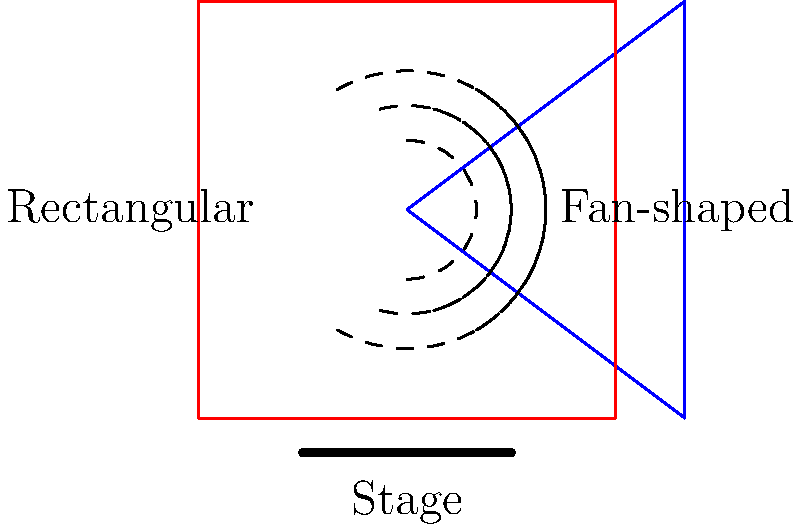As a classical music critic analyzing the interpretation of compositions, which auditorium seating layout would you recommend for optimal sound dispersion and why: fan-shaped or rectangular? To answer this question, we need to consider the acoustical properties of both layouts:

1. Fan-shaped layout:
   a) Provides a wider angle of sound dispersion from the stage.
   b) Reduces the distance between the performers and the audience at the sides.
   c) Minimizes sound reflections from side walls.
   d) Offers better sight lines for the audience.

2. Rectangular layout:
   a) Creates more parallel surfaces for sound reflection.
   b) May produce standing waves and flutter echoes.
   c) Can result in uneven sound distribution, with some areas receiving more direct sound than others.

3. Sound dispersion:
   a) In the fan-shaped layout, sound waves spread more evenly across the audience.
   b) The rectangular layout may have "dead spots" where sound quality is compromised.

4. Interpretation analysis:
   a) A fan-shaped layout allows for better perception of subtle nuances in the performance.
   b) Even sound distribution in the fan-shaped layout ensures a more consistent listening experience for all audience members.

5. Acoustic intimacy:
   a) The fan-shaped layout creates a sense of acoustic intimacy, which is crucial for classical music appreciation.
   b) This intimacy allows for a more accurate analysis of the performers' interpretation.

Given these factors, a classical music critic would likely prefer the fan-shaped layout for its superior sound dispersion properties, which allow for a more accurate and consistent analysis of the musical interpretation across the entire audience area.
Answer: Fan-shaped layout 